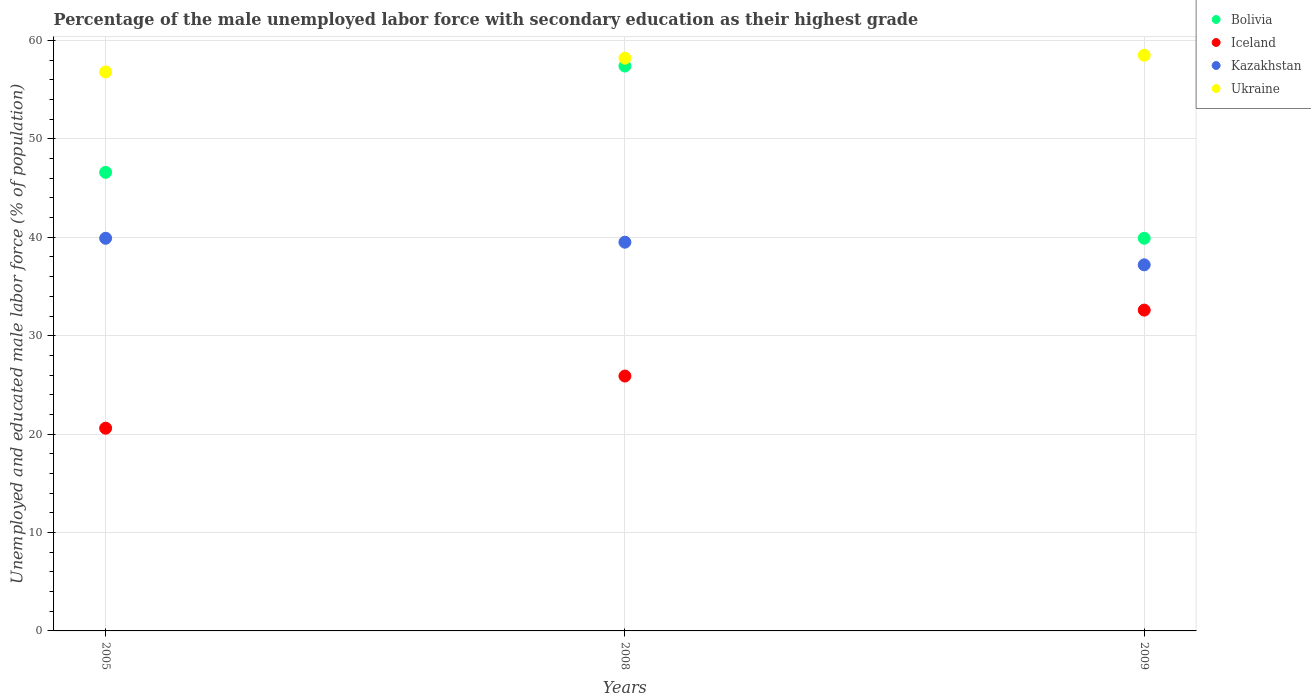Is the number of dotlines equal to the number of legend labels?
Your answer should be compact. Yes. What is the percentage of the unemployed male labor force with secondary education in Bolivia in 2005?
Offer a very short reply. 46.6. Across all years, what is the maximum percentage of the unemployed male labor force with secondary education in Kazakhstan?
Keep it short and to the point. 39.9. Across all years, what is the minimum percentage of the unemployed male labor force with secondary education in Iceland?
Provide a short and direct response. 20.6. What is the total percentage of the unemployed male labor force with secondary education in Bolivia in the graph?
Your answer should be compact. 143.9. What is the difference between the percentage of the unemployed male labor force with secondary education in Bolivia in 2005 and that in 2008?
Ensure brevity in your answer.  -10.8. What is the difference between the percentage of the unemployed male labor force with secondary education in Ukraine in 2005 and the percentage of the unemployed male labor force with secondary education in Bolivia in 2008?
Your response must be concise. -0.6. What is the average percentage of the unemployed male labor force with secondary education in Ukraine per year?
Offer a terse response. 57.83. In the year 2008, what is the difference between the percentage of the unemployed male labor force with secondary education in Kazakhstan and percentage of the unemployed male labor force with secondary education in Bolivia?
Your response must be concise. -17.9. What is the ratio of the percentage of the unemployed male labor force with secondary education in Bolivia in 2005 to that in 2008?
Ensure brevity in your answer.  0.81. Is the percentage of the unemployed male labor force with secondary education in Ukraine in 2005 less than that in 2008?
Your response must be concise. Yes. What is the difference between the highest and the second highest percentage of the unemployed male labor force with secondary education in Kazakhstan?
Your answer should be very brief. 0.4. What is the difference between the highest and the lowest percentage of the unemployed male labor force with secondary education in Kazakhstan?
Give a very brief answer. 2.7. In how many years, is the percentage of the unemployed male labor force with secondary education in Kazakhstan greater than the average percentage of the unemployed male labor force with secondary education in Kazakhstan taken over all years?
Ensure brevity in your answer.  2. Is it the case that in every year, the sum of the percentage of the unemployed male labor force with secondary education in Kazakhstan and percentage of the unemployed male labor force with secondary education in Ukraine  is greater than the percentage of the unemployed male labor force with secondary education in Iceland?
Give a very brief answer. Yes. Is the percentage of the unemployed male labor force with secondary education in Ukraine strictly greater than the percentage of the unemployed male labor force with secondary education in Iceland over the years?
Provide a short and direct response. Yes. Is the percentage of the unemployed male labor force with secondary education in Kazakhstan strictly less than the percentage of the unemployed male labor force with secondary education in Bolivia over the years?
Your answer should be very brief. Yes. What is the difference between two consecutive major ticks on the Y-axis?
Provide a short and direct response. 10. Does the graph contain any zero values?
Provide a succinct answer. No. How many legend labels are there?
Your response must be concise. 4. What is the title of the graph?
Offer a very short reply. Percentage of the male unemployed labor force with secondary education as their highest grade. Does "Channel Islands" appear as one of the legend labels in the graph?
Keep it short and to the point. No. What is the label or title of the X-axis?
Make the answer very short. Years. What is the label or title of the Y-axis?
Your response must be concise. Unemployed and educated male labor force (% of population). What is the Unemployed and educated male labor force (% of population) of Bolivia in 2005?
Your response must be concise. 46.6. What is the Unemployed and educated male labor force (% of population) of Iceland in 2005?
Offer a very short reply. 20.6. What is the Unemployed and educated male labor force (% of population) in Kazakhstan in 2005?
Ensure brevity in your answer.  39.9. What is the Unemployed and educated male labor force (% of population) in Ukraine in 2005?
Make the answer very short. 56.8. What is the Unemployed and educated male labor force (% of population) in Bolivia in 2008?
Keep it short and to the point. 57.4. What is the Unemployed and educated male labor force (% of population) of Iceland in 2008?
Ensure brevity in your answer.  25.9. What is the Unemployed and educated male labor force (% of population) in Kazakhstan in 2008?
Provide a short and direct response. 39.5. What is the Unemployed and educated male labor force (% of population) in Ukraine in 2008?
Make the answer very short. 58.2. What is the Unemployed and educated male labor force (% of population) of Bolivia in 2009?
Provide a succinct answer. 39.9. What is the Unemployed and educated male labor force (% of population) in Iceland in 2009?
Offer a very short reply. 32.6. What is the Unemployed and educated male labor force (% of population) in Kazakhstan in 2009?
Make the answer very short. 37.2. What is the Unemployed and educated male labor force (% of population) in Ukraine in 2009?
Offer a terse response. 58.5. Across all years, what is the maximum Unemployed and educated male labor force (% of population) of Bolivia?
Provide a succinct answer. 57.4. Across all years, what is the maximum Unemployed and educated male labor force (% of population) of Iceland?
Offer a very short reply. 32.6. Across all years, what is the maximum Unemployed and educated male labor force (% of population) of Kazakhstan?
Give a very brief answer. 39.9. Across all years, what is the maximum Unemployed and educated male labor force (% of population) in Ukraine?
Your response must be concise. 58.5. Across all years, what is the minimum Unemployed and educated male labor force (% of population) in Bolivia?
Offer a very short reply. 39.9. Across all years, what is the minimum Unemployed and educated male labor force (% of population) in Iceland?
Your answer should be very brief. 20.6. Across all years, what is the minimum Unemployed and educated male labor force (% of population) of Kazakhstan?
Your answer should be very brief. 37.2. Across all years, what is the minimum Unemployed and educated male labor force (% of population) of Ukraine?
Keep it short and to the point. 56.8. What is the total Unemployed and educated male labor force (% of population) in Bolivia in the graph?
Your response must be concise. 143.9. What is the total Unemployed and educated male labor force (% of population) of Iceland in the graph?
Your response must be concise. 79.1. What is the total Unemployed and educated male labor force (% of population) in Kazakhstan in the graph?
Make the answer very short. 116.6. What is the total Unemployed and educated male labor force (% of population) in Ukraine in the graph?
Ensure brevity in your answer.  173.5. What is the difference between the Unemployed and educated male labor force (% of population) of Iceland in 2005 and that in 2008?
Provide a succinct answer. -5.3. What is the difference between the Unemployed and educated male labor force (% of population) of Kazakhstan in 2005 and that in 2008?
Provide a short and direct response. 0.4. What is the difference between the Unemployed and educated male labor force (% of population) of Kazakhstan in 2005 and that in 2009?
Your answer should be very brief. 2.7. What is the difference between the Unemployed and educated male labor force (% of population) in Ukraine in 2005 and that in 2009?
Make the answer very short. -1.7. What is the difference between the Unemployed and educated male labor force (% of population) in Bolivia in 2008 and that in 2009?
Give a very brief answer. 17.5. What is the difference between the Unemployed and educated male labor force (% of population) in Iceland in 2008 and that in 2009?
Offer a terse response. -6.7. What is the difference between the Unemployed and educated male labor force (% of population) in Ukraine in 2008 and that in 2009?
Ensure brevity in your answer.  -0.3. What is the difference between the Unemployed and educated male labor force (% of population) in Bolivia in 2005 and the Unemployed and educated male labor force (% of population) in Iceland in 2008?
Keep it short and to the point. 20.7. What is the difference between the Unemployed and educated male labor force (% of population) of Iceland in 2005 and the Unemployed and educated male labor force (% of population) of Kazakhstan in 2008?
Make the answer very short. -18.9. What is the difference between the Unemployed and educated male labor force (% of population) of Iceland in 2005 and the Unemployed and educated male labor force (% of population) of Ukraine in 2008?
Your answer should be very brief. -37.6. What is the difference between the Unemployed and educated male labor force (% of population) in Kazakhstan in 2005 and the Unemployed and educated male labor force (% of population) in Ukraine in 2008?
Keep it short and to the point. -18.3. What is the difference between the Unemployed and educated male labor force (% of population) in Bolivia in 2005 and the Unemployed and educated male labor force (% of population) in Ukraine in 2009?
Give a very brief answer. -11.9. What is the difference between the Unemployed and educated male labor force (% of population) of Iceland in 2005 and the Unemployed and educated male labor force (% of population) of Kazakhstan in 2009?
Your answer should be very brief. -16.6. What is the difference between the Unemployed and educated male labor force (% of population) of Iceland in 2005 and the Unemployed and educated male labor force (% of population) of Ukraine in 2009?
Provide a succinct answer. -37.9. What is the difference between the Unemployed and educated male labor force (% of population) of Kazakhstan in 2005 and the Unemployed and educated male labor force (% of population) of Ukraine in 2009?
Give a very brief answer. -18.6. What is the difference between the Unemployed and educated male labor force (% of population) in Bolivia in 2008 and the Unemployed and educated male labor force (% of population) in Iceland in 2009?
Your answer should be compact. 24.8. What is the difference between the Unemployed and educated male labor force (% of population) of Bolivia in 2008 and the Unemployed and educated male labor force (% of population) of Kazakhstan in 2009?
Provide a short and direct response. 20.2. What is the difference between the Unemployed and educated male labor force (% of population) of Iceland in 2008 and the Unemployed and educated male labor force (% of population) of Ukraine in 2009?
Keep it short and to the point. -32.6. What is the difference between the Unemployed and educated male labor force (% of population) in Kazakhstan in 2008 and the Unemployed and educated male labor force (% of population) in Ukraine in 2009?
Your answer should be very brief. -19. What is the average Unemployed and educated male labor force (% of population) in Bolivia per year?
Your answer should be very brief. 47.97. What is the average Unemployed and educated male labor force (% of population) in Iceland per year?
Provide a short and direct response. 26.37. What is the average Unemployed and educated male labor force (% of population) in Kazakhstan per year?
Offer a terse response. 38.87. What is the average Unemployed and educated male labor force (% of population) of Ukraine per year?
Provide a succinct answer. 57.83. In the year 2005, what is the difference between the Unemployed and educated male labor force (% of population) in Bolivia and Unemployed and educated male labor force (% of population) in Kazakhstan?
Your answer should be compact. 6.7. In the year 2005, what is the difference between the Unemployed and educated male labor force (% of population) of Iceland and Unemployed and educated male labor force (% of population) of Kazakhstan?
Give a very brief answer. -19.3. In the year 2005, what is the difference between the Unemployed and educated male labor force (% of population) in Iceland and Unemployed and educated male labor force (% of population) in Ukraine?
Provide a short and direct response. -36.2. In the year 2005, what is the difference between the Unemployed and educated male labor force (% of population) of Kazakhstan and Unemployed and educated male labor force (% of population) of Ukraine?
Provide a short and direct response. -16.9. In the year 2008, what is the difference between the Unemployed and educated male labor force (% of population) in Bolivia and Unemployed and educated male labor force (% of population) in Iceland?
Keep it short and to the point. 31.5. In the year 2008, what is the difference between the Unemployed and educated male labor force (% of population) in Bolivia and Unemployed and educated male labor force (% of population) in Kazakhstan?
Your response must be concise. 17.9. In the year 2008, what is the difference between the Unemployed and educated male labor force (% of population) in Iceland and Unemployed and educated male labor force (% of population) in Kazakhstan?
Your answer should be very brief. -13.6. In the year 2008, what is the difference between the Unemployed and educated male labor force (% of population) of Iceland and Unemployed and educated male labor force (% of population) of Ukraine?
Your answer should be compact. -32.3. In the year 2008, what is the difference between the Unemployed and educated male labor force (% of population) of Kazakhstan and Unemployed and educated male labor force (% of population) of Ukraine?
Ensure brevity in your answer.  -18.7. In the year 2009, what is the difference between the Unemployed and educated male labor force (% of population) of Bolivia and Unemployed and educated male labor force (% of population) of Iceland?
Your answer should be compact. 7.3. In the year 2009, what is the difference between the Unemployed and educated male labor force (% of population) in Bolivia and Unemployed and educated male labor force (% of population) in Kazakhstan?
Give a very brief answer. 2.7. In the year 2009, what is the difference between the Unemployed and educated male labor force (% of population) in Bolivia and Unemployed and educated male labor force (% of population) in Ukraine?
Provide a succinct answer. -18.6. In the year 2009, what is the difference between the Unemployed and educated male labor force (% of population) in Iceland and Unemployed and educated male labor force (% of population) in Ukraine?
Make the answer very short. -25.9. In the year 2009, what is the difference between the Unemployed and educated male labor force (% of population) of Kazakhstan and Unemployed and educated male labor force (% of population) of Ukraine?
Give a very brief answer. -21.3. What is the ratio of the Unemployed and educated male labor force (% of population) of Bolivia in 2005 to that in 2008?
Provide a succinct answer. 0.81. What is the ratio of the Unemployed and educated male labor force (% of population) of Iceland in 2005 to that in 2008?
Your answer should be very brief. 0.8. What is the ratio of the Unemployed and educated male labor force (% of population) of Ukraine in 2005 to that in 2008?
Your answer should be compact. 0.98. What is the ratio of the Unemployed and educated male labor force (% of population) in Bolivia in 2005 to that in 2009?
Make the answer very short. 1.17. What is the ratio of the Unemployed and educated male labor force (% of population) of Iceland in 2005 to that in 2009?
Keep it short and to the point. 0.63. What is the ratio of the Unemployed and educated male labor force (% of population) of Kazakhstan in 2005 to that in 2009?
Offer a terse response. 1.07. What is the ratio of the Unemployed and educated male labor force (% of population) in Ukraine in 2005 to that in 2009?
Your response must be concise. 0.97. What is the ratio of the Unemployed and educated male labor force (% of population) in Bolivia in 2008 to that in 2009?
Make the answer very short. 1.44. What is the ratio of the Unemployed and educated male labor force (% of population) of Iceland in 2008 to that in 2009?
Offer a terse response. 0.79. What is the ratio of the Unemployed and educated male labor force (% of population) in Kazakhstan in 2008 to that in 2009?
Keep it short and to the point. 1.06. What is the difference between the highest and the second highest Unemployed and educated male labor force (% of population) in Kazakhstan?
Offer a very short reply. 0.4. What is the difference between the highest and the second highest Unemployed and educated male labor force (% of population) in Ukraine?
Your response must be concise. 0.3. What is the difference between the highest and the lowest Unemployed and educated male labor force (% of population) of Bolivia?
Ensure brevity in your answer.  17.5. What is the difference between the highest and the lowest Unemployed and educated male labor force (% of population) of Iceland?
Provide a short and direct response. 12. What is the difference between the highest and the lowest Unemployed and educated male labor force (% of population) in Kazakhstan?
Offer a very short reply. 2.7. 